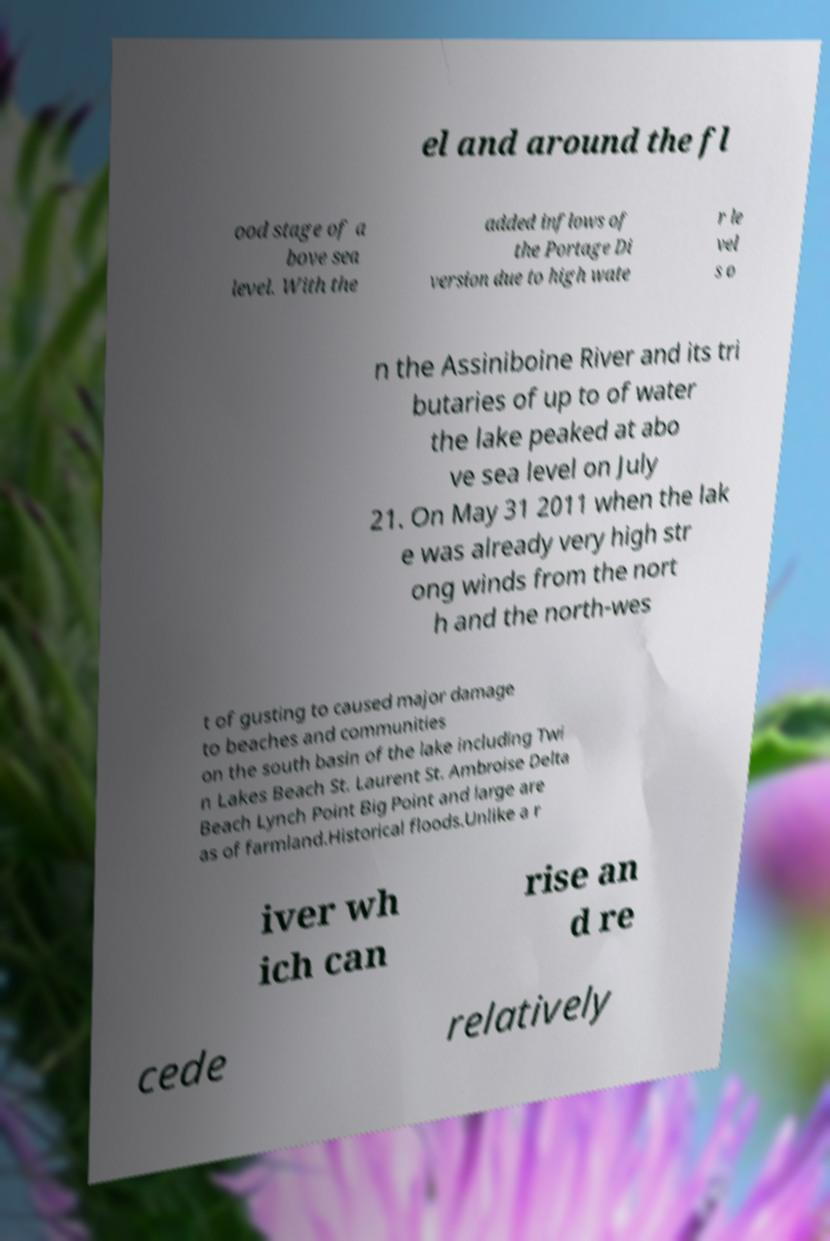There's text embedded in this image that I need extracted. Can you transcribe it verbatim? el and around the fl ood stage of a bove sea level. With the added inflows of the Portage Di version due to high wate r le vel s o n the Assiniboine River and its tri butaries of up to of water the lake peaked at abo ve sea level on July 21. On May 31 2011 when the lak e was already very high str ong winds from the nort h and the north-wes t of gusting to caused major damage to beaches and communities on the south basin of the lake including Twi n Lakes Beach St. Laurent St. Ambroise Delta Beach Lynch Point Big Point and large are as of farmland.Historical floods.Unlike a r iver wh ich can rise an d re cede relatively 